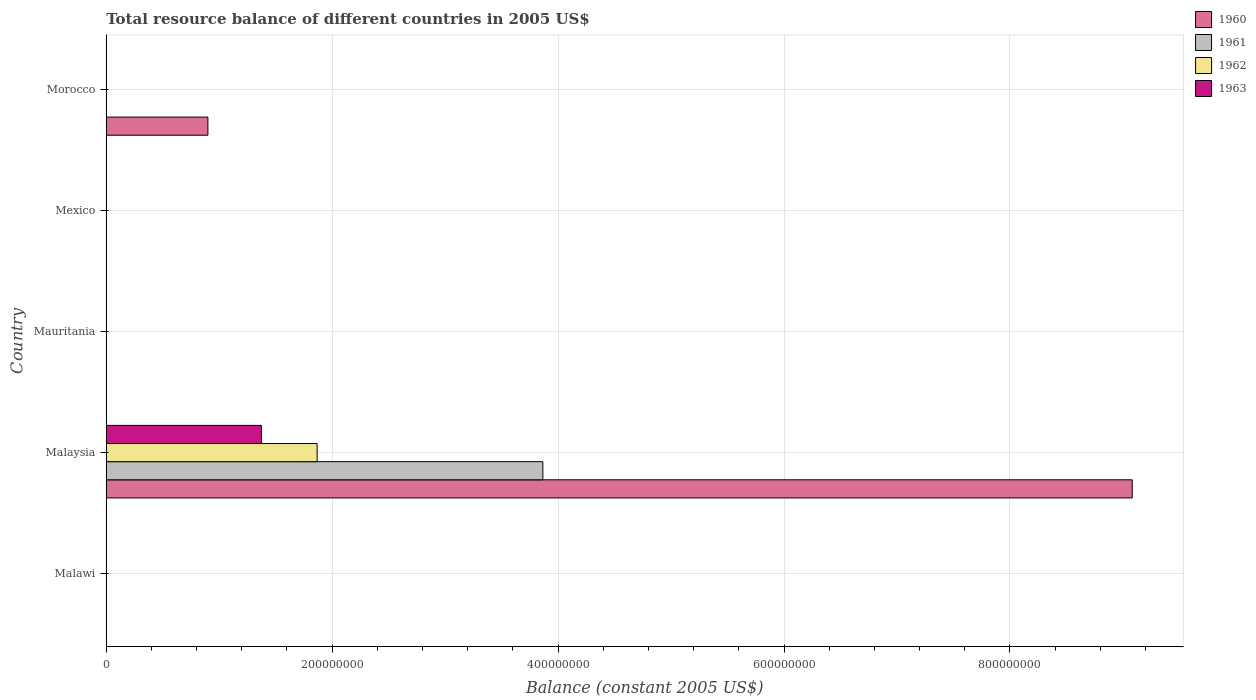How many different coloured bars are there?
Provide a succinct answer. 4. How many bars are there on the 3rd tick from the bottom?
Offer a very short reply. 0. What is the label of the 4th group of bars from the top?
Provide a succinct answer. Malaysia. What is the total resource balance in 1963 in Malaysia?
Make the answer very short. 1.37e+08. Across all countries, what is the maximum total resource balance in 1962?
Provide a short and direct response. 1.87e+08. Across all countries, what is the minimum total resource balance in 1961?
Keep it short and to the point. 0. In which country was the total resource balance in 1961 maximum?
Provide a succinct answer. Malaysia. What is the total total resource balance in 1960 in the graph?
Your answer should be compact. 9.98e+08. What is the difference between the total resource balance in 1963 in Morocco and the total resource balance in 1960 in Mexico?
Provide a succinct answer. 0. What is the average total resource balance in 1962 per country?
Offer a terse response. 3.73e+07. What is the difference between the total resource balance in 1962 and total resource balance in 1960 in Malaysia?
Provide a short and direct response. -7.22e+08. What is the difference between the highest and the lowest total resource balance in 1963?
Ensure brevity in your answer.  1.37e+08. In how many countries, is the total resource balance in 1962 greater than the average total resource balance in 1962 taken over all countries?
Ensure brevity in your answer.  1. Is it the case that in every country, the sum of the total resource balance in 1961 and total resource balance in 1963 is greater than the sum of total resource balance in 1960 and total resource balance in 1962?
Provide a short and direct response. No. What is the difference between two consecutive major ticks on the X-axis?
Provide a succinct answer. 2.00e+08. Are the values on the major ticks of X-axis written in scientific E-notation?
Your answer should be very brief. No. Does the graph contain any zero values?
Keep it short and to the point. Yes. How are the legend labels stacked?
Your answer should be compact. Vertical. What is the title of the graph?
Provide a short and direct response. Total resource balance of different countries in 2005 US$. What is the label or title of the X-axis?
Ensure brevity in your answer.  Balance (constant 2005 US$). What is the Balance (constant 2005 US$) of 1960 in Malawi?
Offer a very short reply. 0. What is the Balance (constant 2005 US$) in 1960 in Malaysia?
Keep it short and to the point. 9.08e+08. What is the Balance (constant 2005 US$) of 1961 in Malaysia?
Offer a terse response. 3.87e+08. What is the Balance (constant 2005 US$) of 1962 in Malaysia?
Provide a short and direct response. 1.87e+08. What is the Balance (constant 2005 US$) in 1963 in Malaysia?
Keep it short and to the point. 1.37e+08. What is the Balance (constant 2005 US$) in 1960 in Mauritania?
Your answer should be very brief. 0. What is the Balance (constant 2005 US$) in 1961 in Mauritania?
Provide a short and direct response. 0. What is the Balance (constant 2005 US$) in 1962 in Mauritania?
Ensure brevity in your answer.  0. What is the Balance (constant 2005 US$) of 1960 in Mexico?
Give a very brief answer. 0. What is the Balance (constant 2005 US$) of 1961 in Mexico?
Give a very brief answer. 0. What is the Balance (constant 2005 US$) in 1962 in Mexico?
Your answer should be very brief. 0. What is the Balance (constant 2005 US$) in 1963 in Mexico?
Provide a short and direct response. 0. What is the Balance (constant 2005 US$) of 1960 in Morocco?
Make the answer very short. 9.00e+07. What is the Balance (constant 2005 US$) of 1961 in Morocco?
Ensure brevity in your answer.  0. Across all countries, what is the maximum Balance (constant 2005 US$) in 1960?
Your answer should be compact. 9.08e+08. Across all countries, what is the maximum Balance (constant 2005 US$) in 1961?
Offer a terse response. 3.87e+08. Across all countries, what is the maximum Balance (constant 2005 US$) in 1962?
Provide a short and direct response. 1.87e+08. Across all countries, what is the maximum Balance (constant 2005 US$) in 1963?
Your answer should be compact. 1.37e+08. Across all countries, what is the minimum Balance (constant 2005 US$) of 1963?
Give a very brief answer. 0. What is the total Balance (constant 2005 US$) of 1960 in the graph?
Your response must be concise. 9.98e+08. What is the total Balance (constant 2005 US$) in 1961 in the graph?
Provide a short and direct response. 3.87e+08. What is the total Balance (constant 2005 US$) in 1962 in the graph?
Keep it short and to the point. 1.87e+08. What is the total Balance (constant 2005 US$) of 1963 in the graph?
Your answer should be compact. 1.37e+08. What is the difference between the Balance (constant 2005 US$) of 1960 in Malaysia and that in Morocco?
Your answer should be very brief. 8.18e+08. What is the average Balance (constant 2005 US$) of 1960 per country?
Offer a terse response. 2.00e+08. What is the average Balance (constant 2005 US$) of 1961 per country?
Your response must be concise. 7.73e+07. What is the average Balance (constant 2005 US$) in 1962 per country?
Make the answer very short. 3.73e+07. What is the average Balance (constant 2005 US$) of 1963 per country?
Ensure brevity in your answer.  2.75e+07. What is the difference between the Balance (constant 2005 US$) in 1960 and Balance (constant 2005 US$) in 1961 in Malaysia?
Your answer should be compact. 5.22e+08. What is the difference between the Balance (constant 2005 US$) of 1960 and Balance (constant 2005 US$) of 1962 in Malaysia?
Offer a terse response. 7.22e+08. What is the difference between the Balance (constant 2005 US$) of 1960 and Balance (constant 2005 US$) of 1963 in Malaysia?
Keep it short and to the point. 7.71e+08. What is the difference between the Balance (constant 2005 US$) in 1961 and Balance (constant 2005 US$) in 1962 in Malaysia?
Give a very brief answer. 2.00e+08. What is the difference between the Balance (constant 2005 US$) of 1961 and Balance (constant 2005 US$) of 1963 in Malaysia?
Keep it short and to the point. 2.49e+08. What is the difference between the Balance (constant 2005 US$) in 1962 and Balance (constant 2005 US$) in 1963 in Malaysia?
Give a very brief answer. 4.93e+07. What is the ratio of the Balance (constant 2005 US$) of 1960 in Malaysia to that in Morocco?
Make the answer very short. 10.09. What is the difference between the highest and the lowest Balance (constant 2005 US$) in 1960?
Your answer should be compact. 9.08e+08. What is the difference between the highest and the lowest Balance (constant 2005 US$) in 1961?
Your answer should be very brief. 3.87e+08. What is the difference between the highest and the lowest Balance (constant 2005 US$) of 1962?
Ensure brevity in your answer.  1.87e+08. What is the difference between the highest and the lowest Balance (constant 2005 US$) of 1963?
Provide a short and direct response. 1.37e+08. 